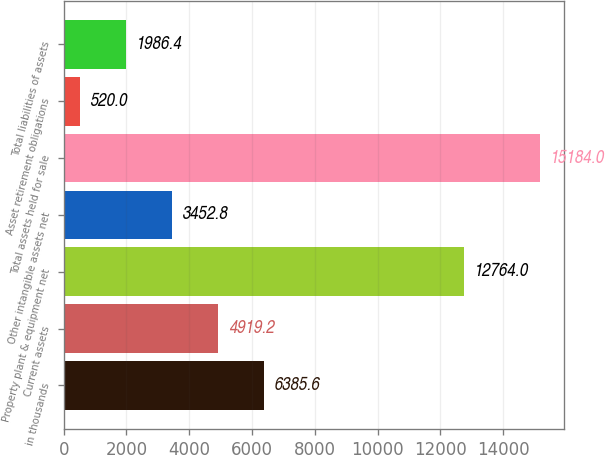<chart> <loc_0><loc_0><loc_500><loc_500><bar_chart><fcel>in thousands<fcel>Current assets<fcel>Property plant & equipment net<fcel>Other intangible assets net<fcel>Total assets held for sale<fcel>Asset retirement obligations<fcel>Total liabilities of assets<nl><fcel>6385.6<fcel>4919.2<fcel>12764<fcel>3452.8<fcel>15184<fcel>520<fcel>1986.4<nl></chart> 